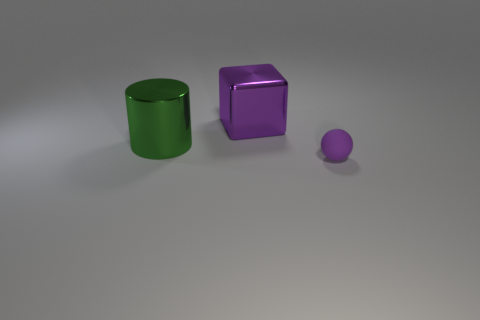Are there an equal number of objects behind the purple matte thing and big green objects to the right of the large purple cube?
Offer a terse response. No. What number of small matte balls have the same color as the big shiny cylinder?
Provide a succinct answer. 0. What material is the big cube that is the same color as the small object?
Your answer should be very brief. Metal. How many rubber objects are either balls or big blocks?
Provide a succinct answer. 1. Do the big thing that is to the left of the large purple shiny thing and the thing right of the block have the same shape?
Give a very brief answer. No. There is a large purple metallic cube; how many objects are in front of it?
Your response must be concise. 2. Is there a small green cube that has the same material as the large cylinder?
Give a very brief answer. No. What material is the cube that is the same size as the green cylinder?
Keep it short and to the point. Metal. Does the big green cylinder have the same material as the small thing?
Offer a terse response. No. How many objects are big brown shiny balls or large shiny cylinders?
Provide a short and direct response. 1. 